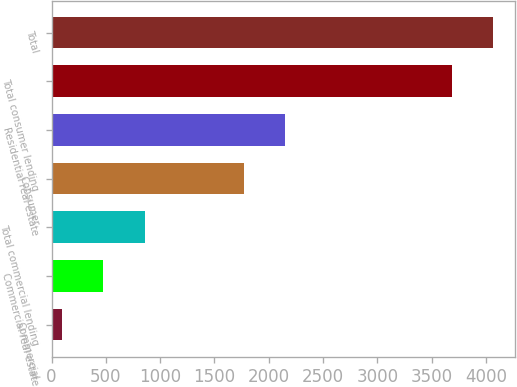Convert chart to OTSL. <chart><loc_0><loc_0><loc_500><loc_500><bar_chart><fcel>Commercial<fcel>Commercial real estate<fcel>Total commercial lending<fcel>Consumer<fcel>Residential real estate<fcel>Total consumer lending<fcel>Total<nl><fcel>94<fcel>477.9<fcel>861.8<fcel>1769<fcel>2152.9<fcel>3684<fcel>4067.9<nl></chart> 